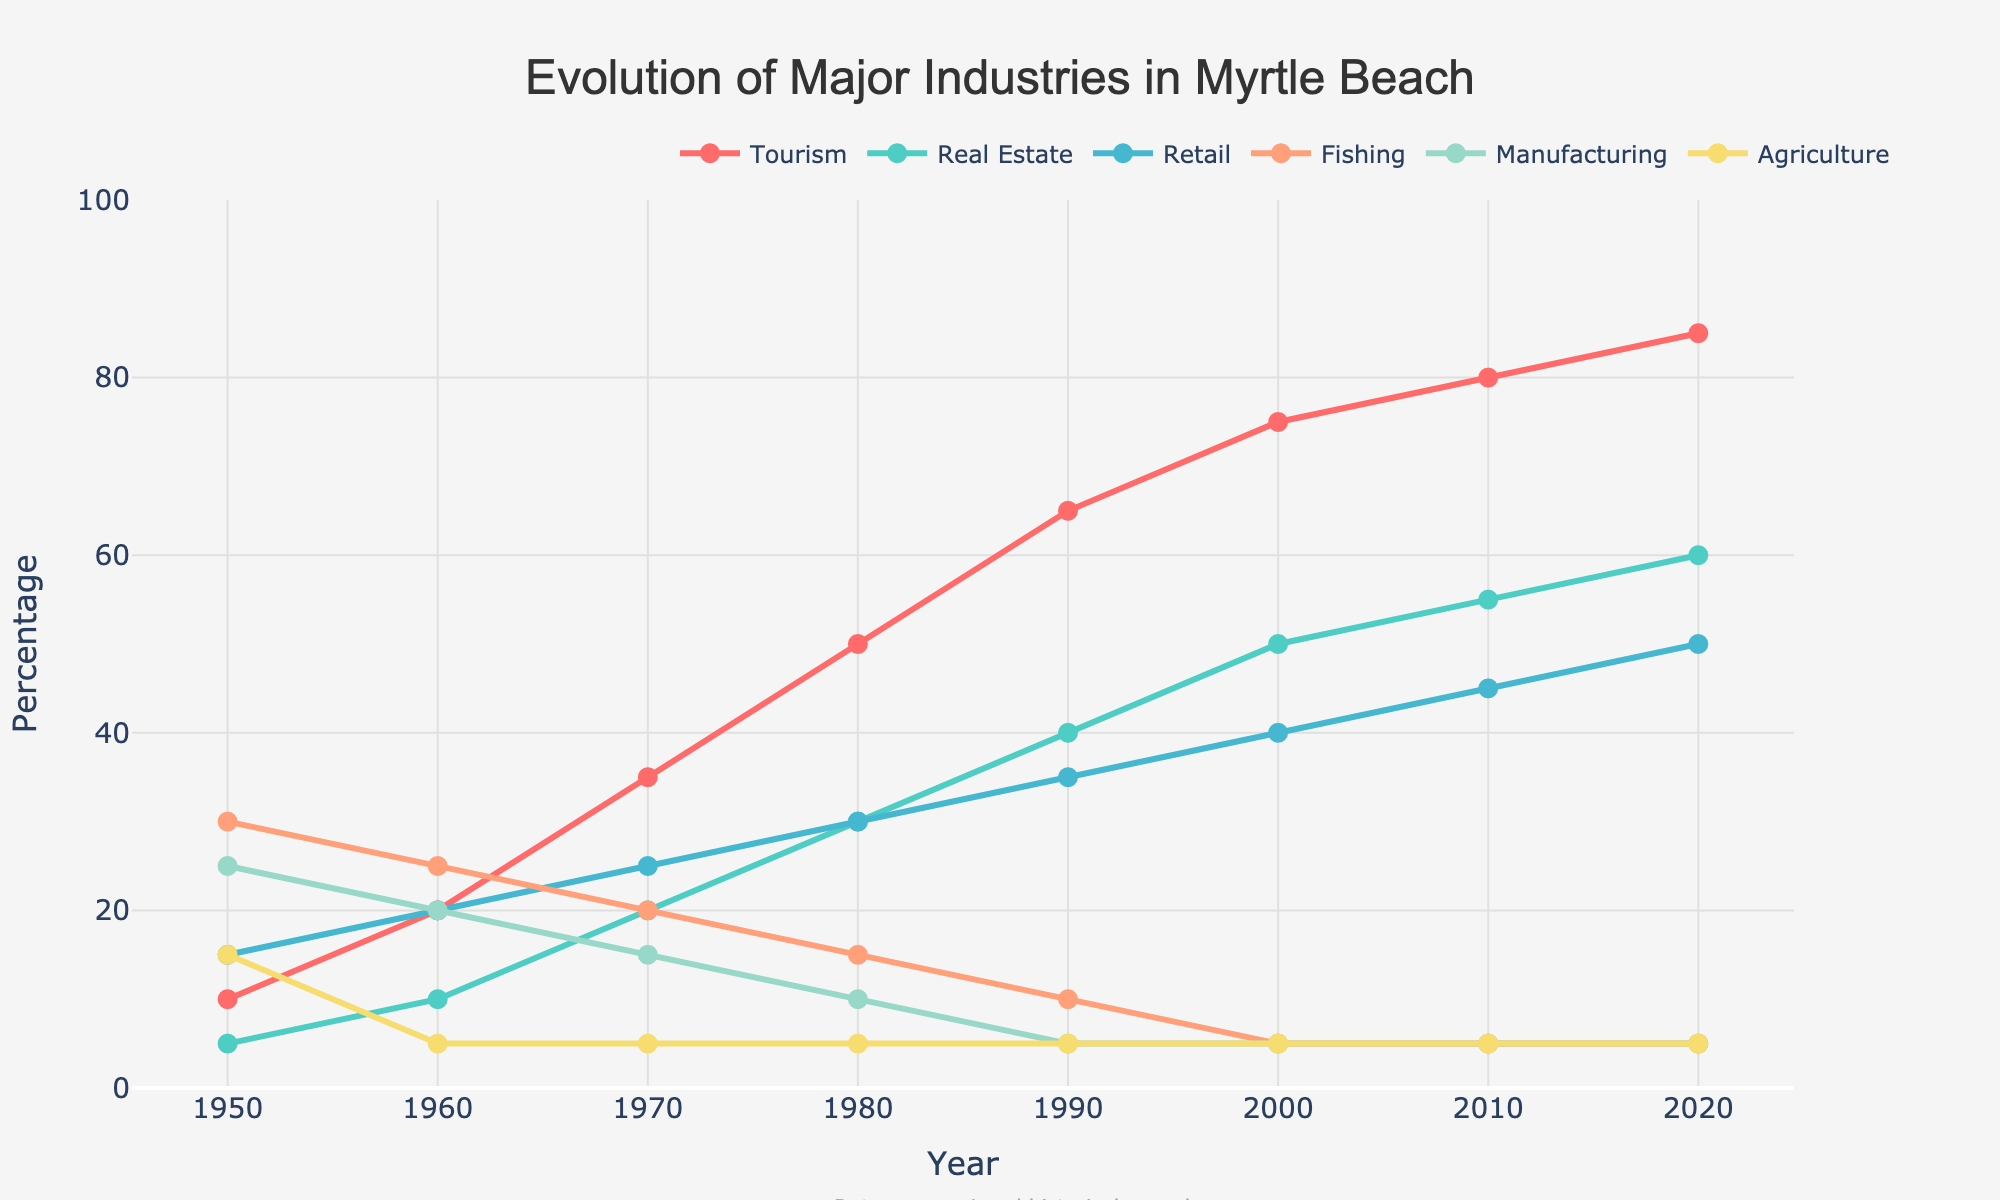What industry saw the most significant increase from 1950 to 2020? To find the industry with the most significant increase, we'll calculate the difference for each industry between 1950 and 2020. Tourism increases from 10 to 85 (75), Real Estate from 5 to 60 (55), Retail from 15 to 50 (35), Fishing decreases from 30 to 5 (-25), Manufacturing decreases from 25 to 5 (-20), and Agriculture remains constant at 15 (0). Thus, Tourism shows the most significant increase.
Answer: Tourism How did the Fishing industry trend from 1950 to 2020? We look at the trend line for the Fishing industry. It starts at 30 in 1950, decreases consistently across the decades, reaching 5 by 2000, and then remains flat at 5 through 2020.
Answer: Consistently declined Which industry had the least change over the period from 1950 to 2020? Comparing changes from 1950 to 2020 for each industry: Tourism (+75), Real Estate (+55), Retail (+35), Fishing (-25), Manufacturing (-20), and Agriculture (0). Agriculture had no change, staying constant at 15.
Answer: Agriculture In 1980, which two industries were equal, and what were their values? Looking at the 1980 values, Real Estate and Retail are both at 30.
Answer: Real Estate and Retail, 30 Which industry surpassed Retail in the 2000s and maintained a lead through 2020? Real Estate overtakes Retail between 1990 and 2000. Retail is at 40 in 2000 while Real Estate is at 50 and continues to be higher through 2020 with 60 while Retail is at 50.
Answer: Real Estate What was the trend for Manufacturing between 1950 and 1980? The Manufacturing industry decreased from 25 in 1950 to 10 in 1980, experiencing a steady decline over the decades.
Answer: Steady decline During which decade did Tourism see the largest growth? To find the largest growth, we observe Tourism values between decades: 1950-10, 1960-20 (+10), 1970-35 (+15), 1980-50 (+15), 1990-65 (+15), 2000-75 (+10), 2010-80 (+5), 2020-85 (+5). The largest growth is between 1960 and 1970, 1970 and 1980, and 1980 and 1990 all at +15.
Answer: 1970-1980 and 1980-1990 